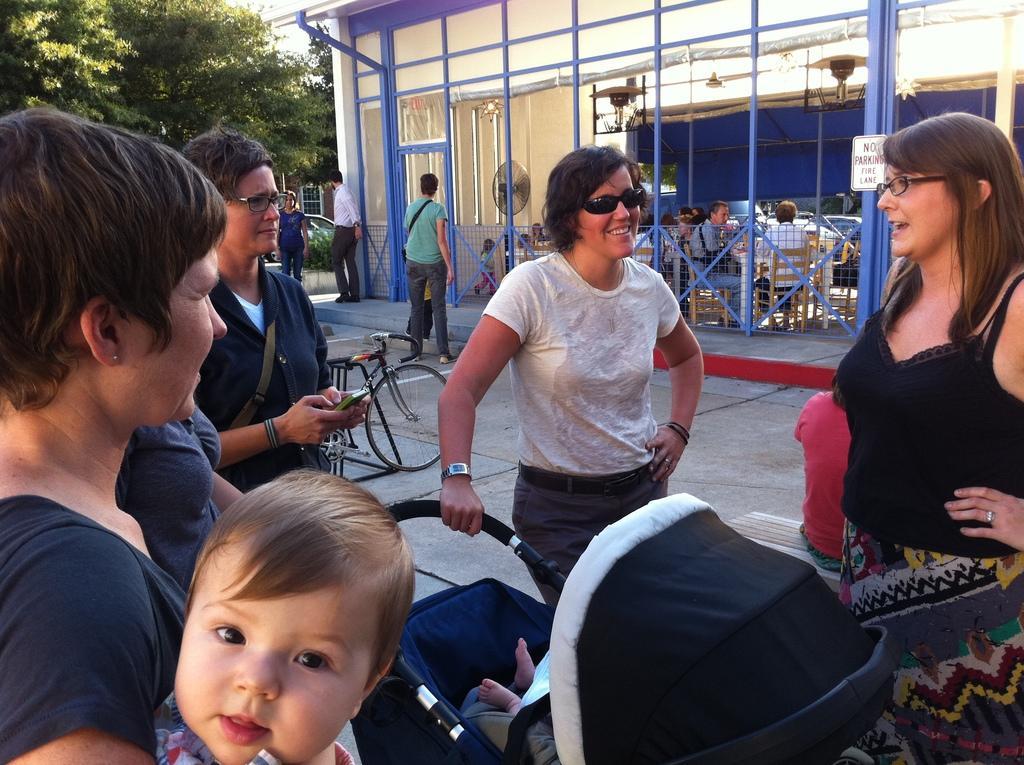How would you summarize this image in a sentence or two? In this image I can see the group of people with different color dresses. I can see a child sitting on the wheelchair. In the back there is a bicycle. I can also see few more people sitting on the chairs. I can also see the board to the pole. In the back there are some trees. 